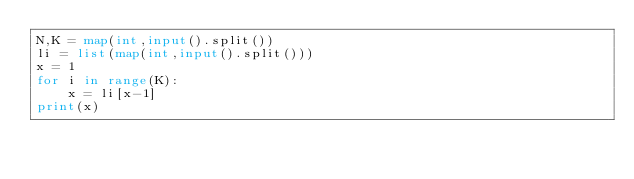Convert code to text. <code><loc_0><loc_0><loc_500><loc_500><_Python_>N,K = map(int,input().split())
li = list(map(int,input().split()))
x = 1
for i in range(K):
    x = li[x-1]
print(x)</code> 